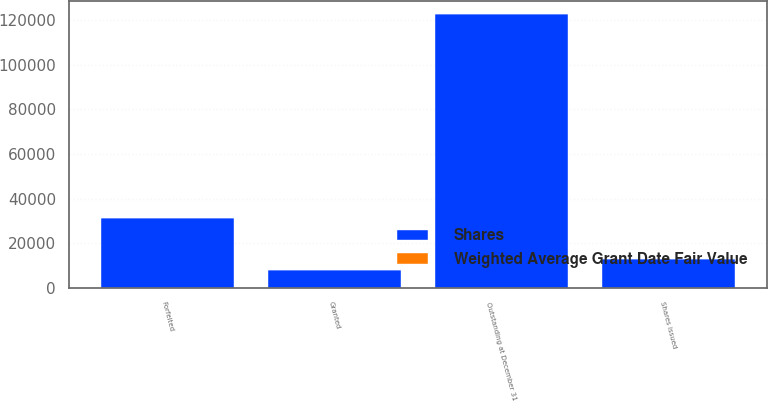<chart> <loc_0><loc_0><loc_500><loc_500><stacked_bar_chart><ecel><fcel>Outstanding at December 31<fcel>Granted<fcel>Shares issued<fcel>Forfeited<nl><fcel>Shares<fcel>122625<fcel>8000<fcel>13000<fcel>31124<nl><fcel>Weighted Average Grant Date Fair Value<fcel>37.18<fcel>43.1<fcel>43.05<fcel>40.19<nl></chart> 